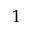<formula> <loc_0><loc_0><loc_500><loc_500>1</formula> 